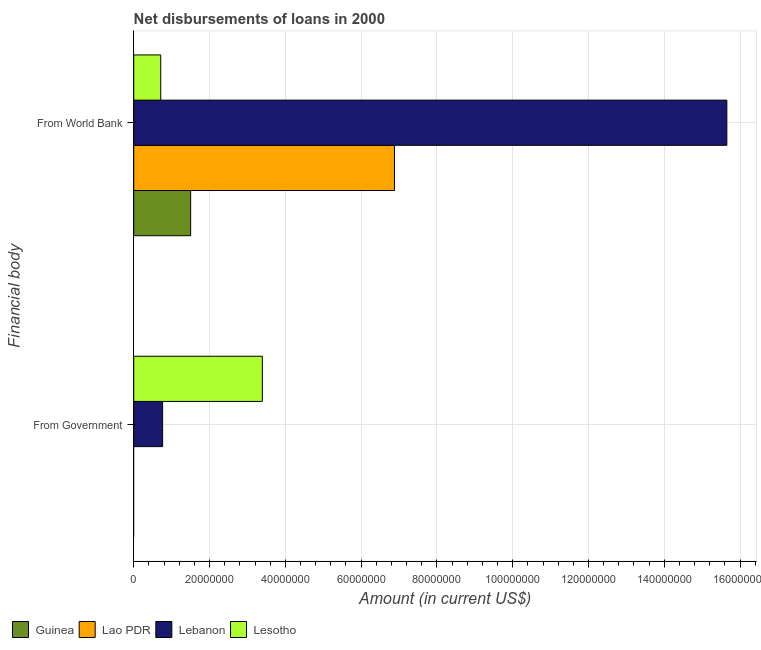How many groups of bars are there?
Ensure brevity in your answer.  2. Are the number of bars per tick equal to the number of legend labels?
Ensure brevity in your answer.  No. Are the number of bars on each tick of the Y-axis equal?
Your answer should be very brief. No. What is the label of the 1st group of bars from the top?
Your answer should be compact. From World Bank. What is the net disbursements of loan from government in Lebanon?
Offer a terse response. 7.62e+06. Across all countries, what is the maximum net disbursements of loan from government?
Ensure brevity in your answer.  3.39e+07. Across all countries, what is the minimum net disbursements of loan from world bank?
Your response must be concise. 7.12e+06. In which country was the net disbursements of loan from world bank maximum?
Your response must be concise. Lebanon. What is the total net disbursements of loan from government in the graph?
Make the answer very short. 4.16e+07. What is the difference between the net disbursements of loan from world bank in Lebanon and that in Guinea?
Give a very brief answer. 1.41e+08. What is the difference between the net disbursements of loan from government in Lao PDR and the net disbursements of loan from world bank in Lesotho?
Provide a succinct answer. -7.12e+06. What is the average net disbursements of loan from world bank per country?
Your answer should be very brief. 6.19e+07. What is the difference between the net disbursements of loan from government and net disbursements of loan from world bank in Lesotho?
Your answer should be compact. 2.68e+07. In how many countries, is the net disbursements of loan from government greater than 64000000 US$?
Make the answer very short. 0. What is the ratio of the net disbursements of loan from world bank in Lebanon to that in Lao PDR?
Give a very brief answer. 2.27. Is the net disbursements of loan from world bank in Lesotho less than that in Lao PDR?
Offer a terse response. Yes. In how many countries, is the net disbursements of loan from government greater than the average net disbursements of loan from government taken over all countries?
Your response must be concise. 1. How many bars are there?
Your answer should be very brief. 6. What is the difference between two consecutive major ticks on the X-axis?
Offer a terse response. 2.00e+07. Are the values on the major ticks of X-axis written in scientific E-notation?
Make the answer very short. No. Where does the legend appear in the graph?
Provide a succinct answer. Bottom left. How are the legend labels stacked?
Make the answer very short. Horizontal. What is the title of the graph?
Your response must be concise. Net disbursements of loans in 2000. What is the label or title of the X-axis?
Keep it short and to the point. Amount (in current US$). What is the label or title of the Y-axis?
Your answer should be compact. Financial body. What is the Amount (in current US$) in Lao PDR in From Government?
Provide a succinct answer. 0. What is the Amount (in current US$) in Lebanon in From Government?
Your answer should be compact. 7.62e+06. What is the Amount (in current US$) of Lesotho in From Government?
Offer a very short reply. 3.39e+07. What is the Amount (in current US$) in Guinea in From World Bank?
Offer a terse response. 1.50e+07. What is the Amount (in current US$) in Lao PDR in From World Bank?
Your answer should be compact. 6.88e+07. What is the Amount (in current US$) of Lebanon in From World Bank?
Provide a succinct answer. 1.57e+08. What is the Amount (in current US$) in Lesotho in From World Bank?
Make the answer very short. 7.12e+06. Across all Financial body, what is the maximum Amount (in current US$) in Guinea?
Your response must be concise. 1.50e+07. Across all Financial body, what is the maximum Amount (in current US$) of Lao PDR?
Offer a very short reply. 6.88e+07. Across all Financial body, what is the maximum Amount (in current US$) in Lebanon?
Keep it short and to the point. 1.57e+08. Across all Financial body, what is the maximum Amount (in current US$) of Lesotho?
Your response must be concise. 3.39e+07. Across all Financial body, what is the minimum Amount (in current US$) of Lao PDR?
Offer a terse response. 0. Across all Financial body, what is the minimum Amount (in current US$) in Lebanon?
Ensure brevity in your answer.  7.62e+06. Across all Financial body, what is the minimum Amount (in current US$) of Lesotho?
Offer a very short reply. 7.12e+06. What is the total Amount (in current US$) in Guinea in the graph?
Offer a very short reply. 1.50e+07. What is the total Amount (in current US$) of Lao PDR in the graph?
Provide a short and direct response. 6.88e+07. What is the total Amount (in current US$) of Lebanon in the graph?
Offer a very short reply. 1.64e+08. What is the total Amount (in current US$) of Lesotho in the graph?
Make the answer very short. 4.11e+07. What is the difference between the Amount (in current US$) in Lebanon in From Government and that in From World Bank?
Offer a very short reply. -1.49e+08. What is the difference between the Amount (in current US$) in Lesotho in From Government and that in From World Bank?
Provide a short and direct response. 2.68e+07. What is the difference between the Amount (in current US$) of Lebanon in From Government and the Amount (in current US$) of Lesotho in From World Bank?
Offer a very short reply. 5.03e+05. What is the average Amount (in current US$) in Guinea per Financial body?
Give a very brief answer. 7.51e+06. What is the average Amount (in current US$) in Lao PDR per Financial body?
Keep it short and to the point. 3.44e+07. What is the average Amount (in current US$) in Lebanon per Financial body?
Your response must be concise. 8.21e+07. What is the average Amount (in current US$) in Lesotho per Financial body?
Your answer should be very brief. 2.05e+07. What is the difference between the Amount (in current US$) of Lebanon and Amount (in current US$) of Lesotho in From Government?
Your response must be concise. -2.63e+07. What is the difference between the Amount (in current US$) in Guinea and Amount (in current US$) in Lao PDR in From World Bank?
Give a very brief answer. -5.38e+07. What is the difference between the Amount (in current US$) in Guinea and Amount (in current US$) in Lebanon in From World Bank?
Provide a succinct answer. -1.41e+08. What is the difference between the Amount (in current US$) of Guinea and Amount (in current US$) of Lesotho in From World Bank?
Ensure brevity in your answer.  7.90e+06. What is the difference between the Amount (in current US$) of Lao PDR and Amount (in current US$) of Lebanon in From World Bank?
Provide a short and direct response. -8.77e+07. What is the difference between the Amount (in current US$) in Lao PDR and Amount (in current US$) in Lesotho in From World Bank?
Give a very brief answer. 6.17e+07. What is the difference between the Amount (in current US$) of Lebanon and Amount (in current US$) of Lesotho in From World Bank?
Offer a very short reply. 1.49e+08. What is the ratio of the Amount (in current US$) of Lebanon in From Government to that in From World Bank?
Offer a very short reply. 0.05. What is the ratio of the Amount (in current US$) of Lesotho in From Government to that in From World Bank?
Your response must be concise. 4.77. What is the difference between the highest and the second highest Amount (in current US$) of Lebanon?
Offer a very short reply. 1.49e+08. What is the difference between the highest and the second highest Amount (in current US$) in Lesotho?
Offer a terse response. 2.68e+07. What is the difference between the highest and the lowest Amount (in current US$) in Guinea?
Ensure brevity in your answer.  1.50e+07. What is the difference between the highest and the lowest Amount (in current US$) of Lao PDR?
Your answer should be compact. 6.88e+07. What is the difference between the highest and the lowest Amount (in current US$) of Lebanon?
Your response must be concise. 1.49e+08. What is the difference between the highest and the lowest Amount (in current US$) in Lesotho?
Your answer should be compact. 2.68e+07. 